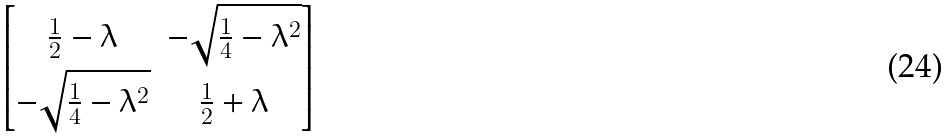<formula> <loc_0><loc_0><loc_500><loc_500>\begin{bmatrix} \frac { 1 } { 2 } - \lambda & - \sqrt { \frac { 1 } { 4 } - \lambda ^ { 2 } } \\ - \sqrt { \frac { 1 } { 4 } - \lambda ^ { 2 } } & \frac { 1 } { 2 } + \lambda \end{bmatrix}</formula> 